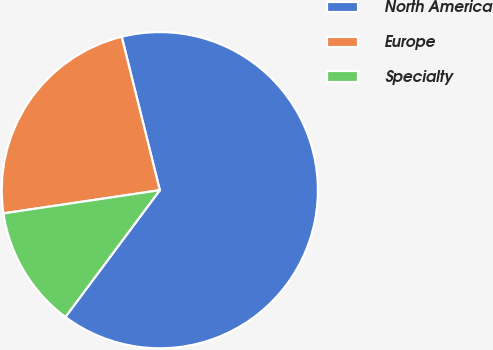<chart> <loc_0><loc_0><loc_500><loc_500><pie_chart><fcel>North America<fcel>Europe<fcel>Specialty<nl><fcel>64.06%<fcel>23.47%<fcel>12.47%<nl></chart> 